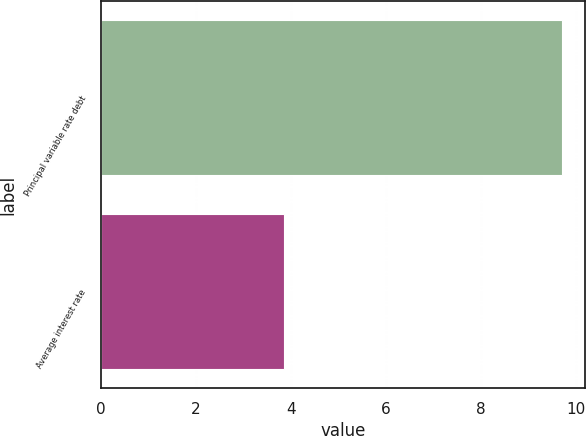<chart> <loc_0><loc_0><loc_500><loc_500><bar_chart><fcel>Principal variable rate debt<fcel>Average interest rate<nl><fcel>9.7<fcel>3.86<nl></chart> 